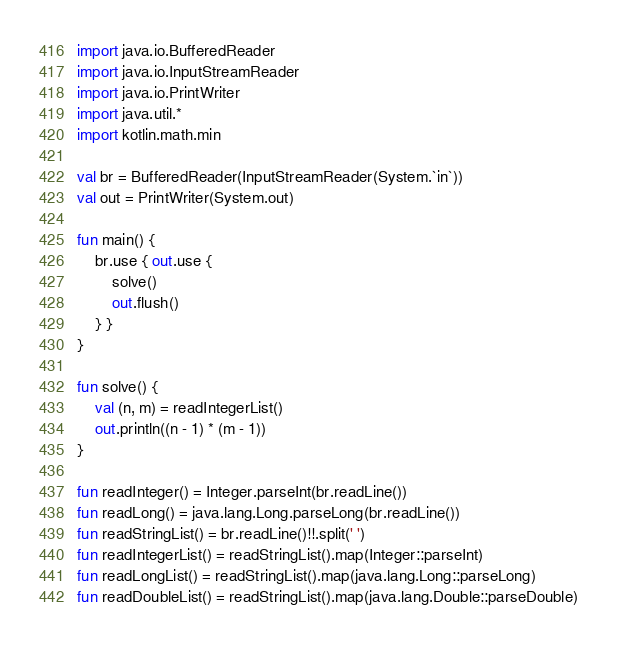Convert code to text. <code><loc_0><loc_0><loc_500><loc_500><_Kotlin_>import java.io.BufferedReader
import java.io.InputStreamReader
import java.io.PrintWriter
import java.util.*
import kotlin.math.min

val br = BufferedReader(InputStreamReader(System.`in`))
val out = PrintWriter(System.out)

fun main() {
    br.use { out.use {
        solve()
        out.flush()
    } }
}

fun solve() {
    val (n, m) = readIntegerList()
    out.println((n - 1) * (m - 1))
}

fun readInteger() = Integer.parseInt(br.readLine())
fun readLong() = java.lang.Long.parseLong(br.readLine())
fun readStringList() = br.readLine()!!.split(' ')
fun readIntegerList() = readStringList().map(Integer::parseInt)
fun readLongList() = readStringList().map(java.lang.Long::parseLong)
fun readDoubleList() = readStringList().map(java.lang.Double::parseDouble)
</code> 